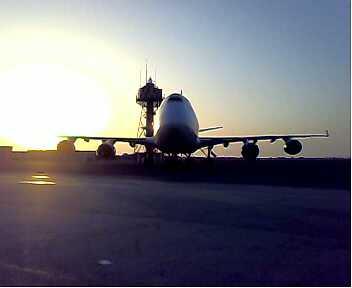Does this aircraft have propellers?
Write a very short answer. No. What time of day is it?
Answer briefly. Morning. Is it going to rain soon?
Answer briefly. No. 